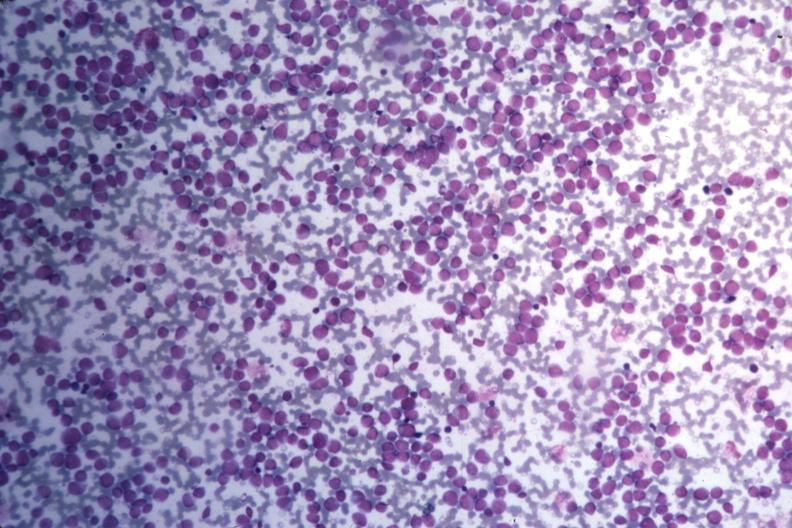s hematologic present?
Answer the question using a single word or phrase. Yes 